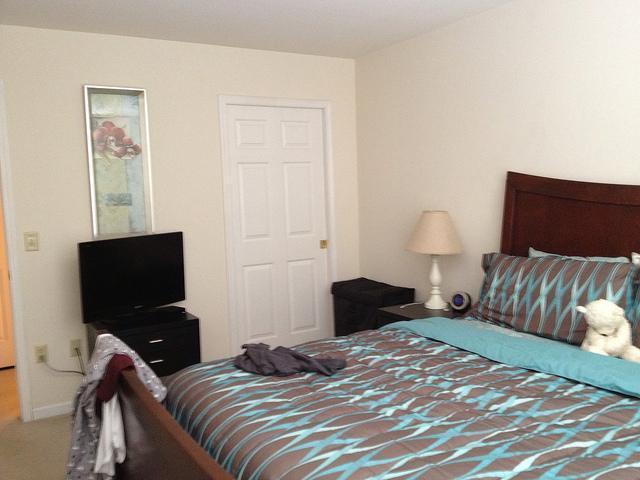How many teddy bears are visible?
Give a very brief answer. 1. 